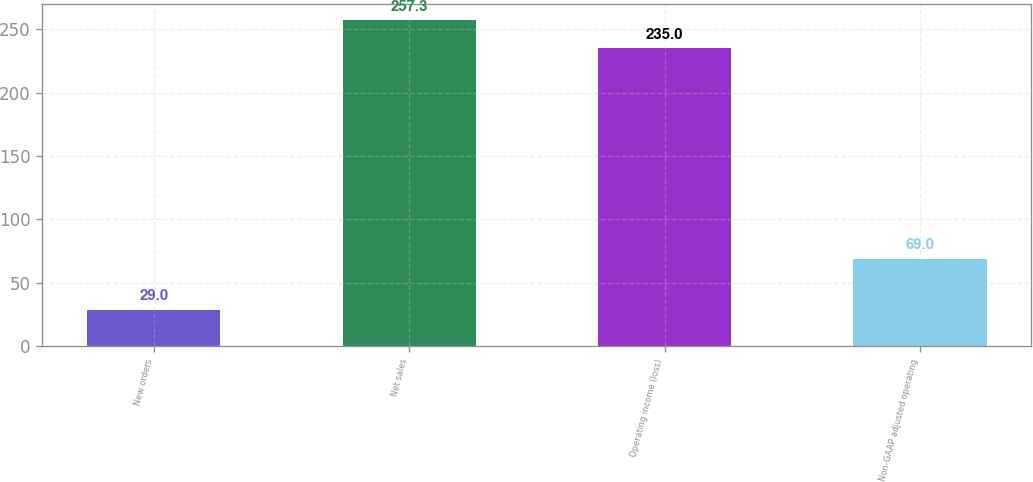Convert chart. <chart><loc_0><loc_0><loc_500><loc_500><bar_chart><fcel>New orders<fcel>Net sales<fcel>Operating income (loss)<fcel>Non-GAAP adjusted operating<nl><fcel>29<fcel>257.3<fcel>235<fcel>69<nl></chart> 